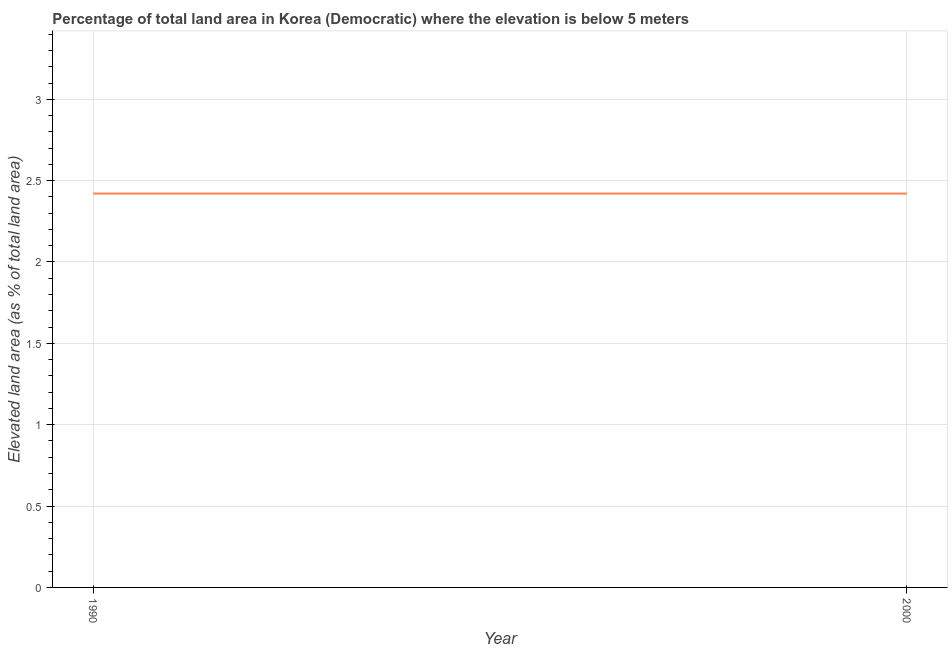What is the total elevated land area in 1990?
Make the answer very short. 2.42. Across all years, what is the maximum total elevated land area?
Ensure brevity in your answer.  2.42. Across all years, what is the minimum total elevated land area?
Your answer should be very brief. 2.42. What is the sum of the total elevated land area?
Your answer should be compact. 4.84. What is the average total elevated land area per year?
Your answer should be compact. 2.42. What is the median total elevated land area?
Your answer should be compact. 2.42. In how many years, is the total elevated land area greater than 3.2 %?
Provide a short and direct response. 0. What is the ratio of the total elevated land area in 1990 to that in 2000?
Your response must be concise. 1. Is the total elevated land area in 1990 less than that in 2000?
Keep it short and to the point. No. Does the total elevated land area monotonically increase over the years?
Your answer should be very brief. No. How many lines are there?
Give a very brief answer. 1. Are the values on the major ticks of Y-axis written in scientific E-notation?
Give a very brief answer. No. Does the graph contain grids?
Provide a succinct answer. Yes. What is the title of the graph?
Make the answer very short. Percentage of total land area in Korea (Democratic) where the elevation is below 5 meters. What is the label or title of the Y-axis?
Ensure brevity in your answer.  Elevated land area (as % of total land area). What is the Elevated land area (as % of total land area) of 1990?
Offer a very short reply. 2.42. What is the Elevated land area (as % of total land area) of 2000?
Provide a short and direct response. 2.42. 